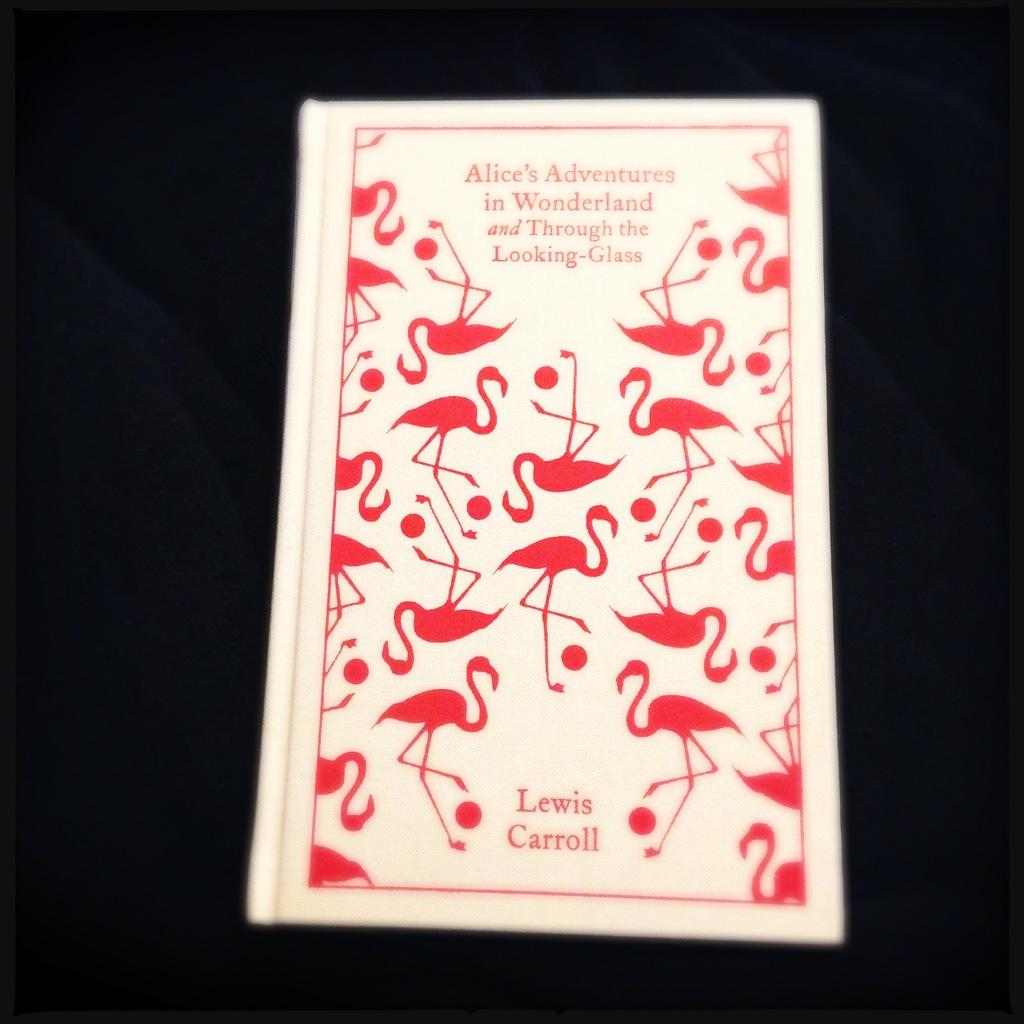Who is the author?
Give a very brief answer. Lewis carroll. According to the book title, what did alice go through?
Make the answer very short. The looking glass. 